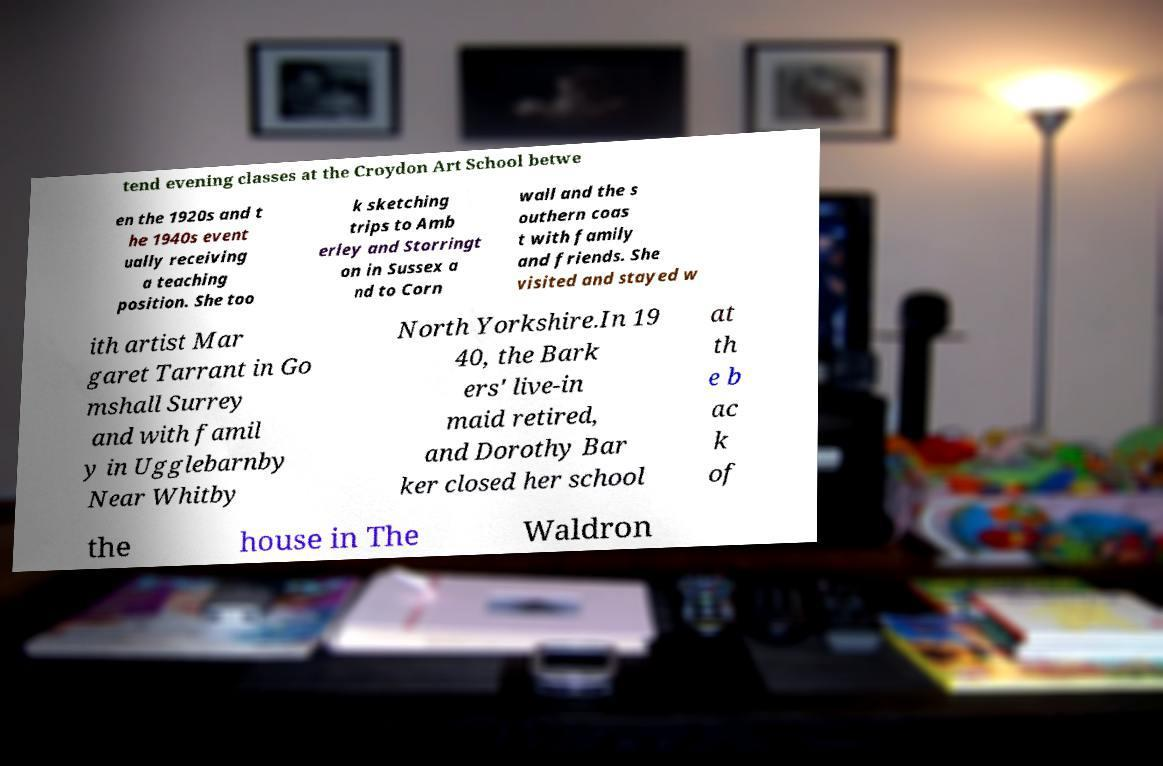What messages or text are displayed in this image? I need them in a readable, typed format. tend evening classes at the Croydon Art School betwe en the 1920s and t he 1940s event ually receiving a teaching position. She too k sketching trips to Amb erley and Storringt on in Sussex a nd to Corn wall and the s outhern coas t with family and friends. She visited and stayed w ith artist Mar garet Tarrant in Go mshall Surrey and with famil y in Ugglebarnby Near Whitby North Yorkshire.In 19 40, the Bark ers' live-in maid retired, and Dorothy Bar ker closed her school at th e b ac k of the house in The Waldron 